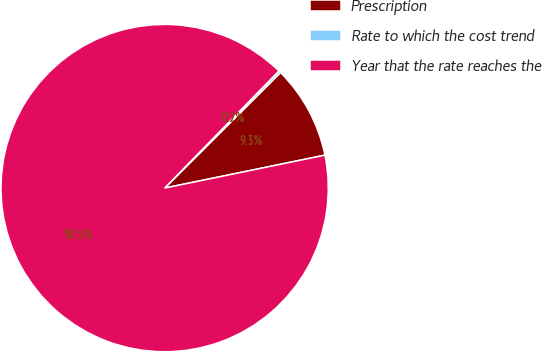Convert chart. <chart><loc_0><loc_0><loc_500><loc_500><pie_chart><fcel>Prescription<fcel>Rate to which the cost trend<fcel>Year that the rate reaches the<nl><fcel>9.25%<fcel>0.22%<fcel>90.52%<nl></chart> 